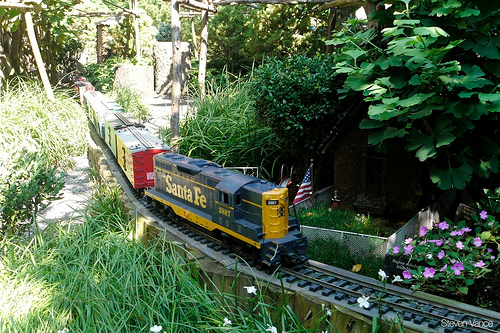Please provide a short description for this region: [0.32, 0.51, 0.42, 0.58]. The text 'Santa Fe' is written prominently on the side of the train. 